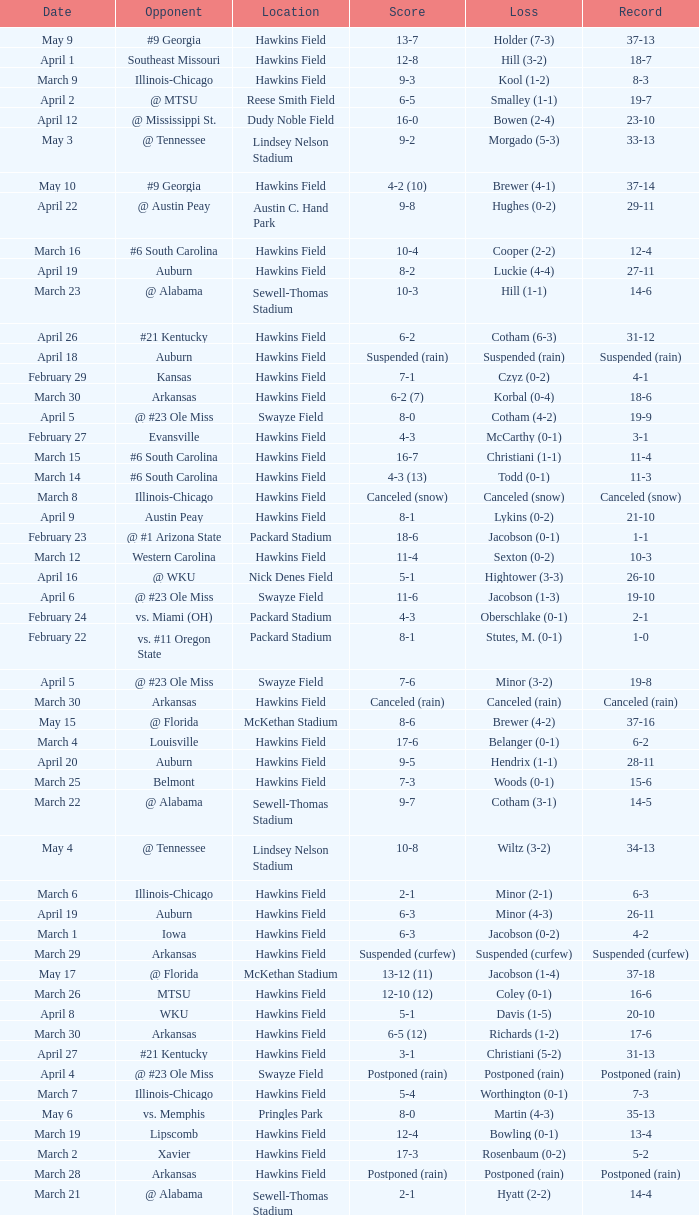What was the location of the game when the record was 2-1? Packard Stadium. 